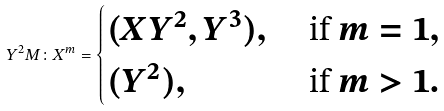<formula> <loc_0><loc_0><loc_500><loc_500>Y ^ { 2 } M \colon X ^ { m } = \begin{cases} ( X Y ^ { 2 } , Y ^ { 3 } ) , & \text { if } m = 1 , \\ ( Y ^ { 2 } ) , & \text { if } m > 1 . \end{cases}</formula> 